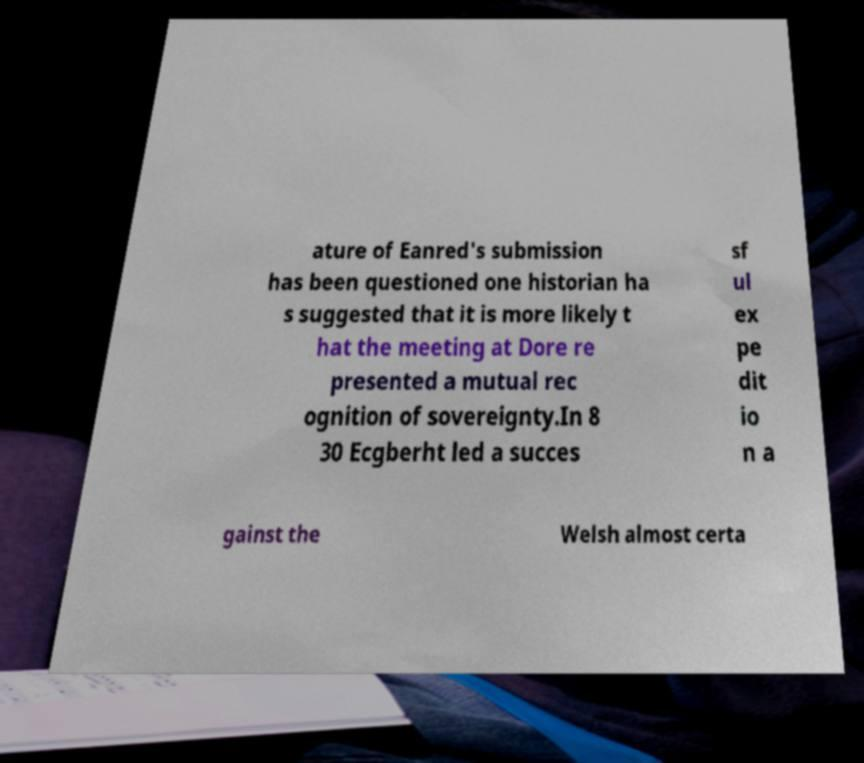Could you assist in decoding the text presented in this image and type it out clearly? ature of Eanred's submission has been questioned one historian ha s suggested that it is more likely t hat the meeting at Dore re presented a mutual rec ognition of sovereignty.In 8 30 Ecgberht led a succes sf ul ex pe dit io n a gainst the Welsh almost certa 